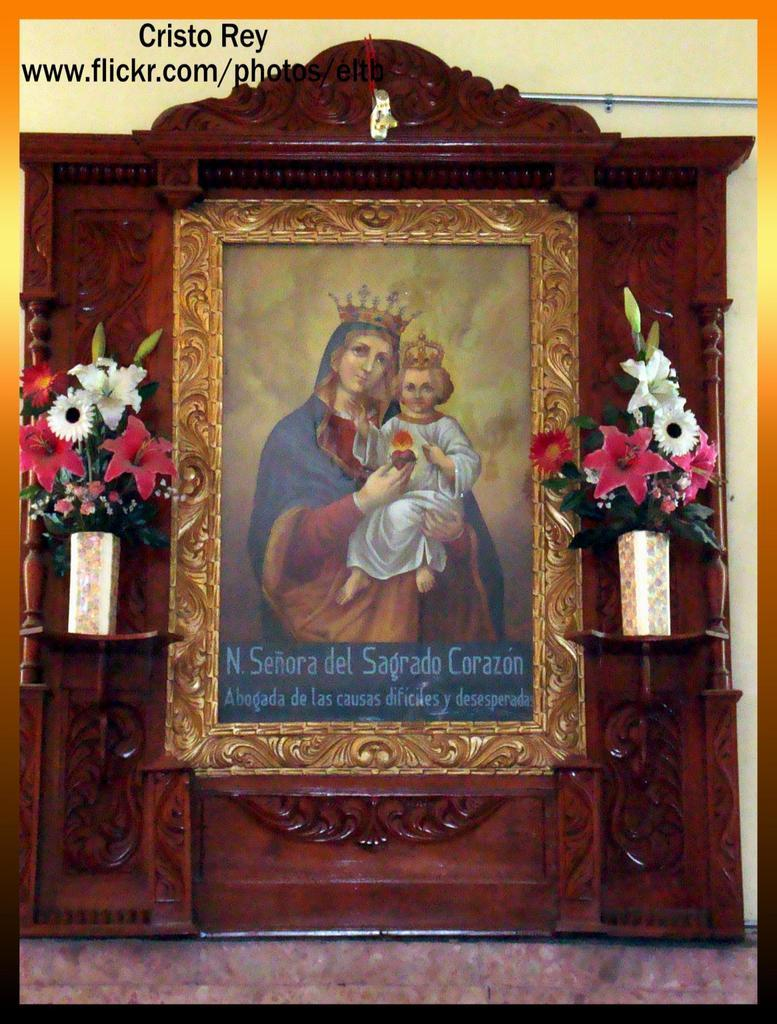<image>
Provide a brief description of the given image. An ornate painting of a woman and a child with the words N senora del sagrado corazon. 